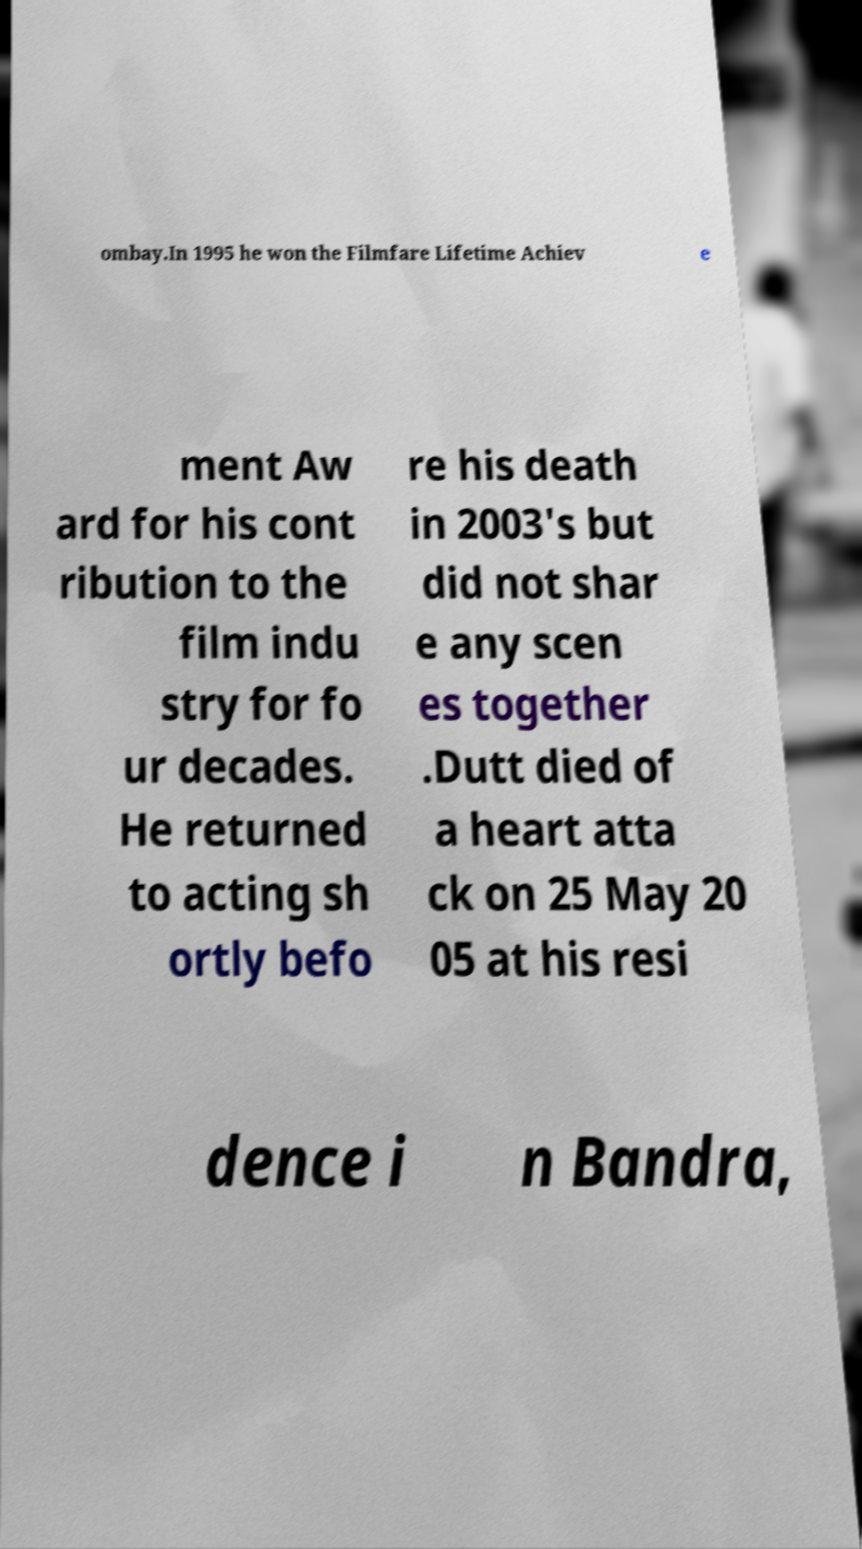Could you assist in decoding the text presented in this image and type it out clearly? ombay.In 1995 he won the Filmfare Lifetime Achiev e ment Aw ard for his cont ribution to the film indu stry for fo ur decades. He returned to acting sh ortly befo re his death in 2003's but did not shar e any scen es together .Dutt died of a heart atta ck on 25 May 20 05 at his resi dence i n Bandra, 